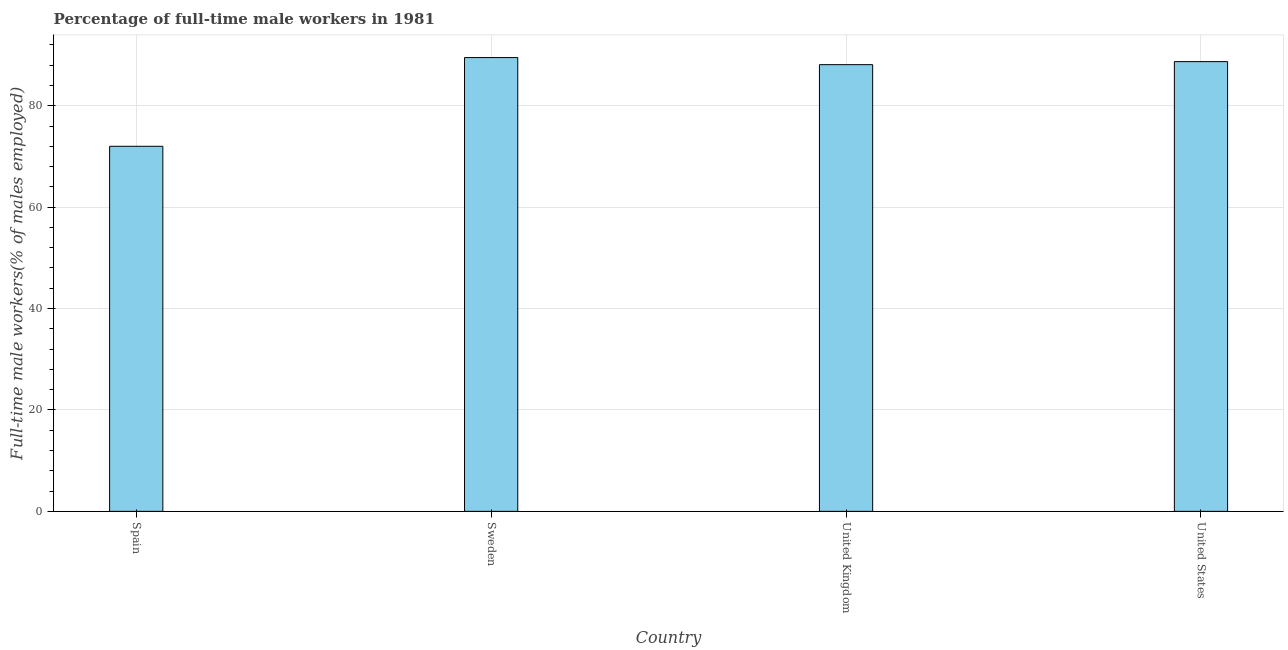What is the title of the graph?
Offer a terse response. Percentage of full-time male workers in 1981. What is the label or title of the X-axis?
Keep it short and to the point. Country. What is the label or title of the Y-axis?
Offer a terse response. Full-time male workers(% of males employed). What is the percentage of full-time male workers in United Kingdom?
Your answer should be very brief. 88.1. Across all countries, what is the maximum percentage of full-time male workers?
Keep it short and to the point. 89.5. Across all countries, what is the minimum percentage of full-time male workers?
Provide a succinct answer. 72. In which country was the percentage of full-time male workers maximum?
Keep it short and to the point. Sweden. What is the sum of the percentage of full-time male workers?
Offer a very short reply. 338.3. What is the difference between the percentage of full-time male workers in United Kingdom and United States?
Your answer should be compact. -0.6. What is the average percentage of full-time male workers per country?
Your answer should be compact. 84.58. What is the median percentage of full-time male workers?
Provide a succinct answer. 88.4. In how many countries, is the percentage of full-time male workers greater than 20 %?
Provide a succinct answer. 4. What is the ratio of the percentage of full-time male workers in Spain to that in Sweden?
Your answer should be very brief. 0.8. Is the difference between the percentage of full-time male workers in Spain and Sweden greater than the difference between any two countries?
Keep it short and to the point. Yes. Is the sum of the percentage of full-time male workers in Spain and Sweden greater than the maximum percentage of full-time male workers across all countries?
Provide a short and direct response. Yes. What is the difference between the highest and the lowest percentage of full-time male workers?
Keep it short and to the point. 17.5. In how many countries, is the percentage of full-time male workers greater than the average percentage of full-time male workers taken over all countries?
Make the answer very short. 3. Are all the bars in the graph horizontal?
Provide a short and direct response. No. What is the difference between two consecutive major ticks on the Y-axis?
Make the answer very short. 20. Are the values on the major ticks of Y-axis written in scientific E-notation?
Offer a very short reply. No. What is the Full-time male workers(% of males employed) in Sweden?
Offer a terse response. 89.5. What is the Full-time male workers(% of males employed) in United Kingdom?
Ensure brevity in your answer.  88.1. What is the Full-time male workers(% of males employed) in United States?
Your response must be concise. 88.7. What is the difference between the Full-time male workers(% of males employed) in Spain and Sweden?
Keep it short and to the point. -17.5. What is the difference between the Full-time male workers(% of males employed) in Spain and United Kingdom?
Ensure brevity in your answer.  -16.1. What is the difference between the Full-time male workers(% of males employed) in Spain and United States?
Your answer should be compact. -16.7. What is the difference between the Full-time male workers(% of males employed) in Sweden and United Kingdom?
Give a very brief answer. 1.4. What is the difference between the Full-time male workers(% of males employed) in United Kingdom and United States?
Give a very brief answer. -0.6. What is the ratio of the Full-time male workers(% of males employed) in Spain to that in Sweden?
Your answer should be very brief. 0.8. What is the ratio of the Full-time male workers(% of males employed) in Spain to that in United Kingdom?
Provide a short and direct response. 0.82. What is the ratio of the Full-time male workers(% of males employed) in Spain to that in United States?
Your answer should be very brief. 0.81. 